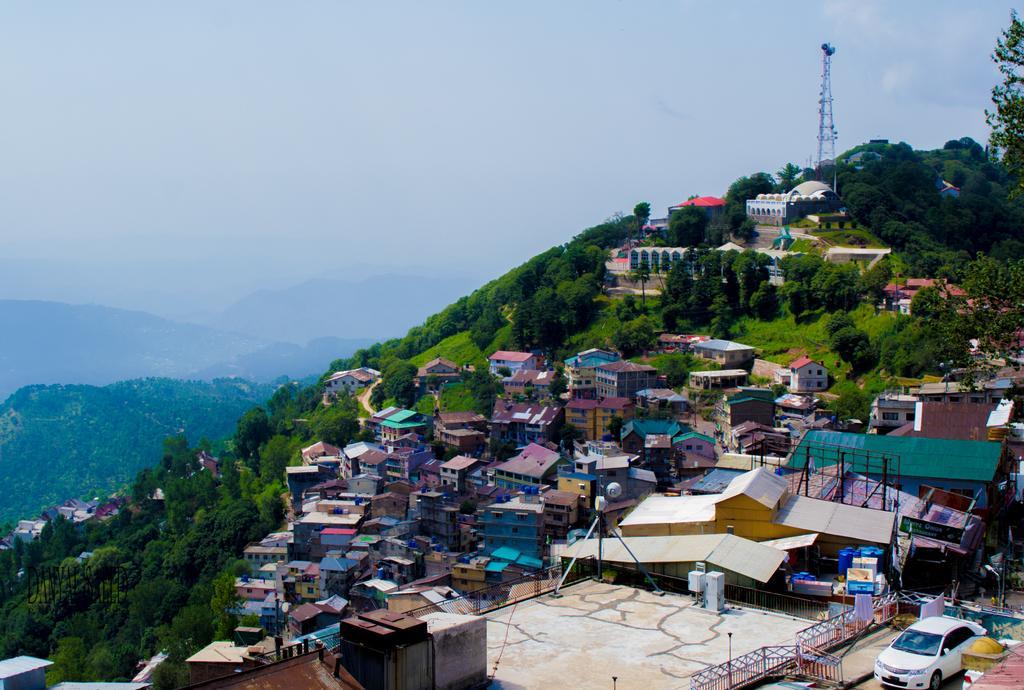In one or two sentences, can you explain what this image depicts? In the foreground I can see a playground, fence, metal rods, vehicles on the road, light poles, houses, buildings, trees, mountains, grass, wall and a tower. In the background I can see a fog and the sky. This image is taken may be during a day. 